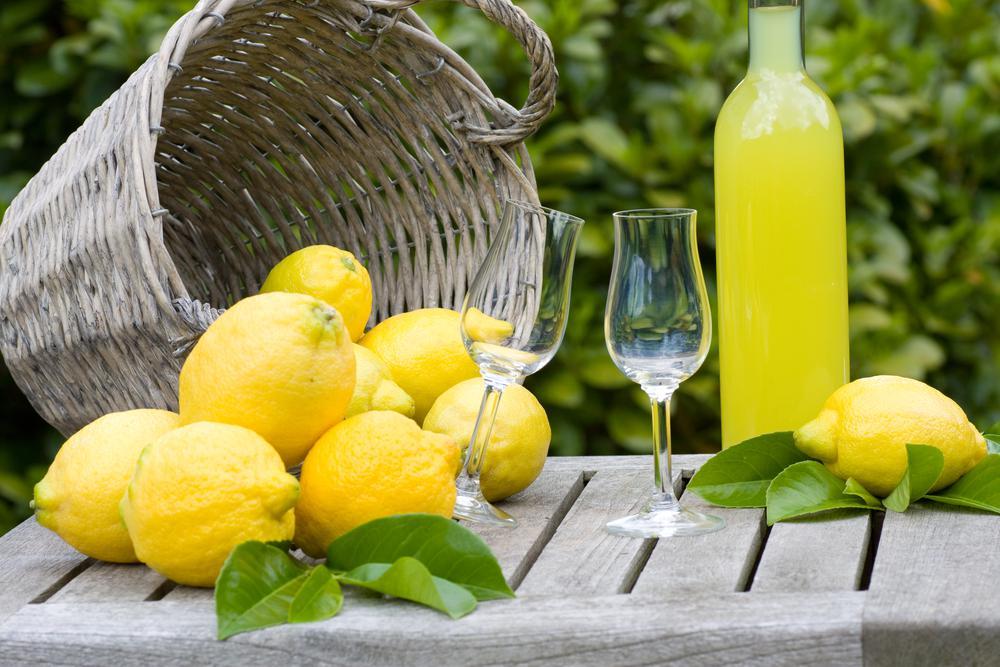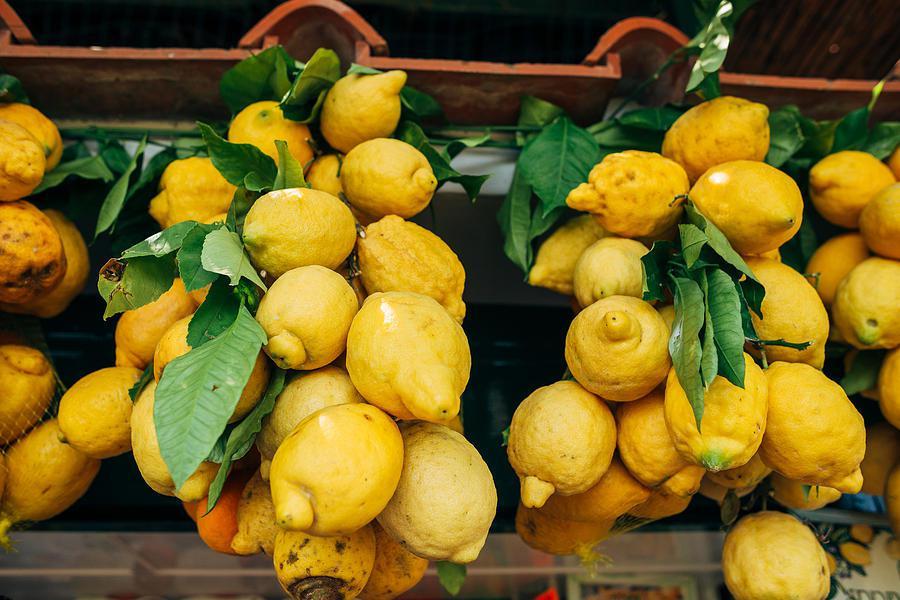The first image is the image on the left, the second image is the image on the right. Evaluate the accuracy of this statement regarding the images: "In at least one image there are no more then four lemons with leaves under them". Is it true? Answer yes or no. No. The first image is the image on the left, the second image is the image on the right. Evaluate the accuracy of this statement regarding the images: "The left image includes a yellow plastic basket containing large yellow dimpled fruits, some with green leaves attached.". Is it true? Answer yes or no. No. 